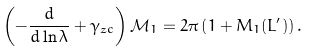<formula> <loc_0><loc_0><loc_500><loc_500>\left ( - \frac { d } { d \ln \lambda } + \gamma _ { z c } \right ) \mathcal { M } _ { 1 } = 2 \pi \left ( 1 + M _ { 1 } ( L ^ { \prime } ) \right ) .</formula> 